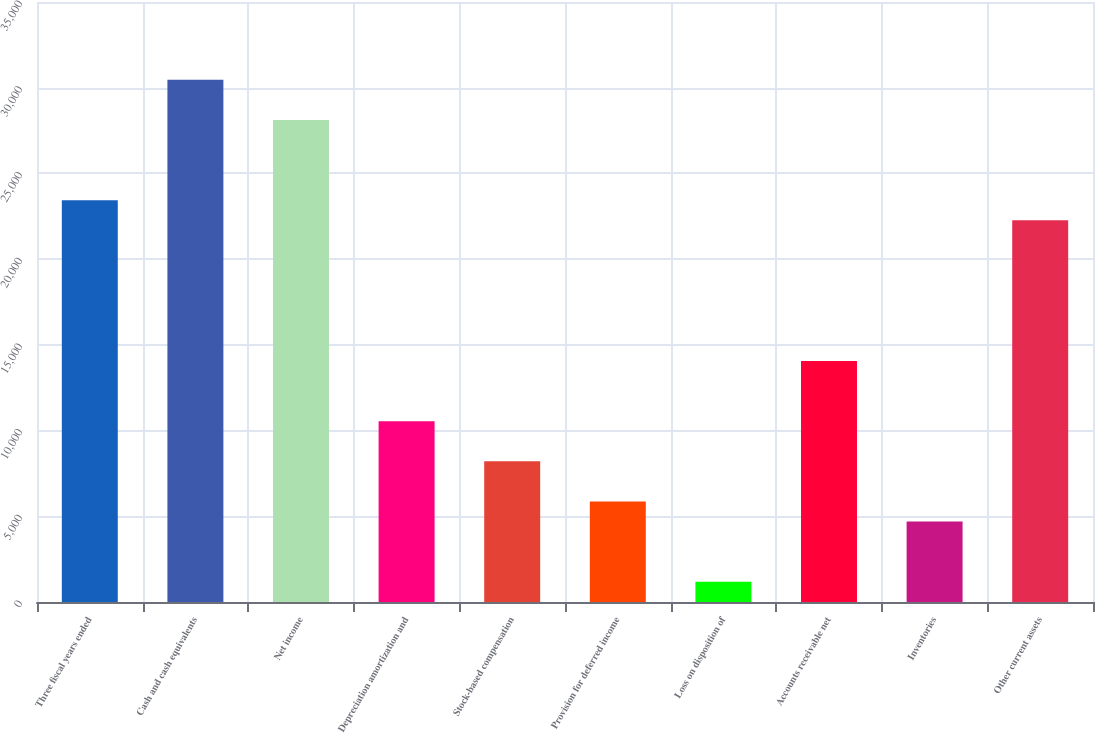Convert chart to OTSL. <chart><loc_0><loc_0><loc_500><loc_500><bar_chart><fcel>Three fiscal years ended<fcel>Cash and cash equivalents<fcel>Net income<fcel>Depreciation amortization and<fcel>Stock-based compensation<fcel>Provision for deferred income<fcel>Loss on disposition of<fcel>Accounts receivable net<fcel>Inventories<fcel>Other current assets<nl><fcel>23435<fcel>30464.6<fcel>28121.4<fcel>10547.4<fcel>8204.2<fcel>5861<fcel>1174.6<fcel>14062.2<fcel>4689.4<fcel>22263.4<nl></chart> 